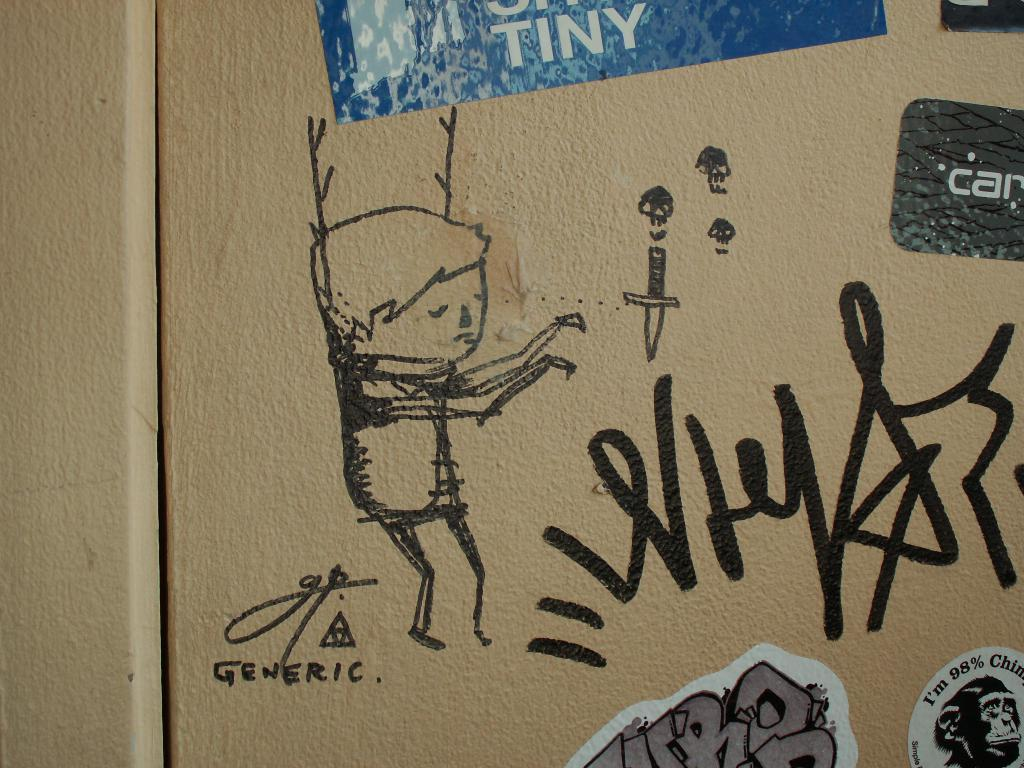What is the main subject of the image? The main subject of the image is a drawing. Where are papers located in the image? Papers are posted at the top and bottom of the image. What type of grass is growing in the image? There is no grass present in the image; it features a drawing and papers. What is the title of the drawing in the image? The provided facts do not mention a title for the drawing, so we cannot determine the title from the image. 